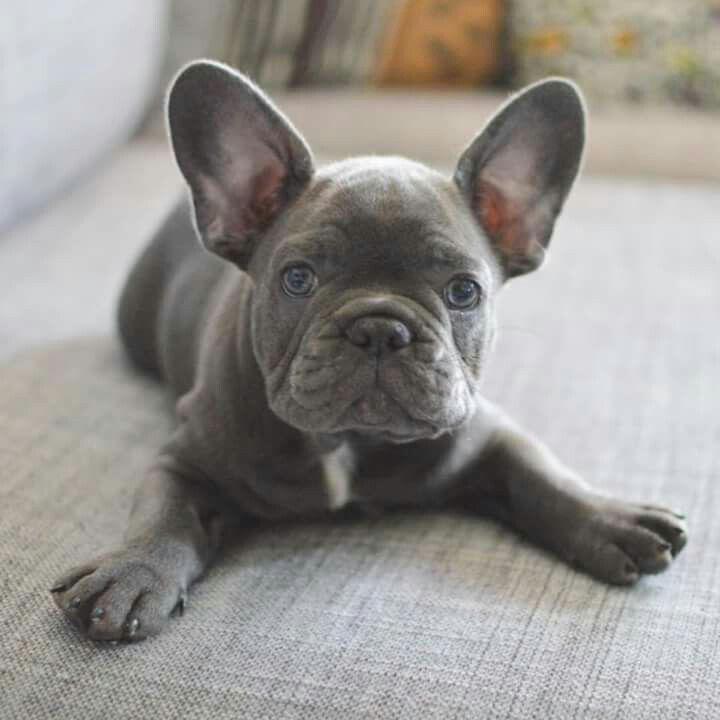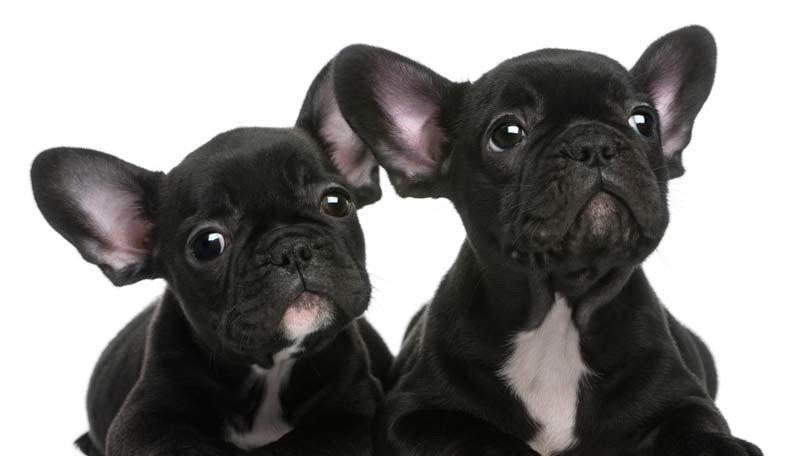The first image is the image on the left, the second image is the image on the right. Assess this claim about the two images: "A single black dog is opposite at least three dogs of multiple colors.". Correct or not? Answer yes or no. No. 